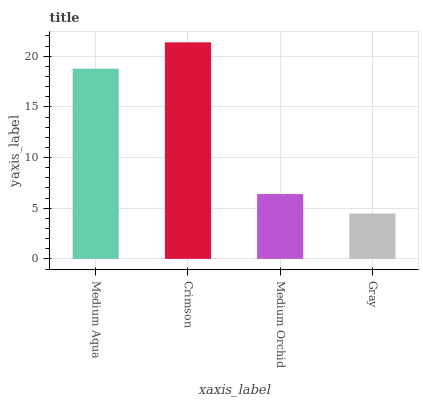Is Medium Orchid the minimum?
Answer yes or no. No. Is Medium Orchid the maximum?
Answer yes or no. No. Is Crimson greater than Medium Orchid?
Answer yes or no. Yes. Is Medium Orchid less than Crimson?
Answer yes or no. Yes. Is Medium Orchid greater than Crimson?
Answer yes or no. No. Is Crimson less than Medium Orchid?
Answer yes or no. No. Is Medium Aqua the high median?
Answer yes or no. Yes. Is Medium Orchid the low median?
Answer yes or no. Yes. Is Medium Orchid the high median?
Answer yes or no. No. Is Medium Aqua the low median?
Answer yes or no. No. 